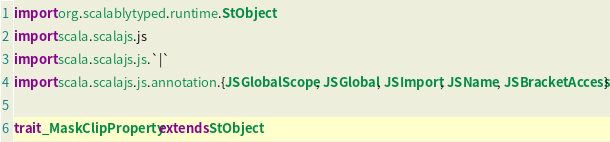Convert code to text. <code><loc_0><loc_0><loc_500><loc_500><_Scala_>import org.scalablytyped.runtime.StObject
import scala.scalajs.js
import scala.scalajs.js.`|`
import scala.scalajs.js.annotation.{JSGlobalScope, JSGlobal, JSImport, JSName, JSBracketAccess}

trait _MaskClipProperty extends StObject
</code> 